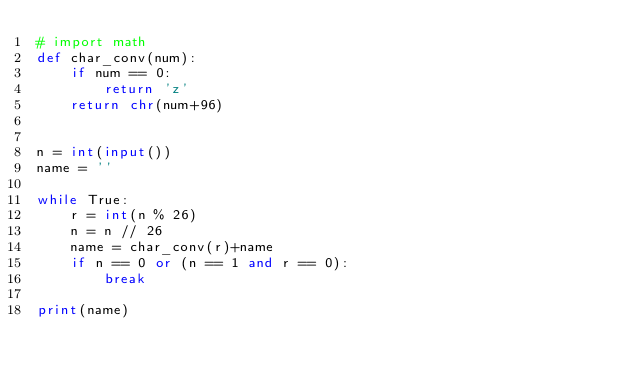Convert code to text. <code><loc_0><loc_0><loc_500><loc_500><_Python_># import math
def char_conv(num):
    if num == 0:
        return 'z'
    return chr(num+96)


n = int(input())
name = ''

while True:
    r = int(n % 26)
    n = n // 26
    name = char_conv(r)+name
    if n == 0 or (n == 1 and r == 0):
        break

print(name)
</code> 